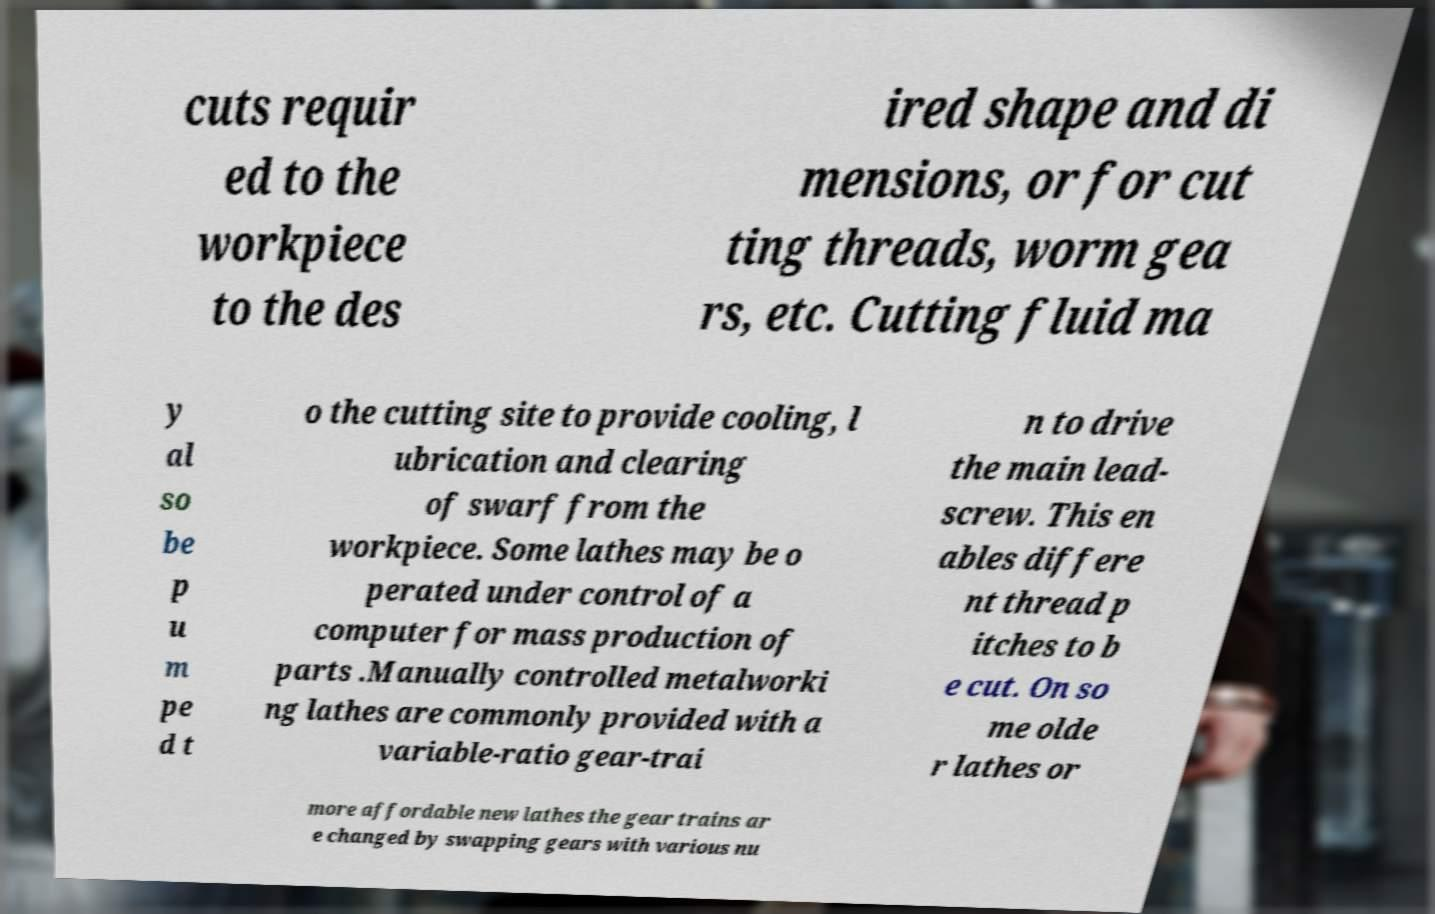Could you assist in decoding the text presented in this image and type it out clearly? cuts requir ed to the workpiece to the des ired shape and di mensions, or for cut ting threads, worm gea rs, etc. Cutting fluid ma y al so be p u m pe d t o the cutting site to provide cooling, l ubrication and clearing of swarf from the workpiece. Some lathes may be o perated under control of a computer for mass production of parts .Manually controlled metalworki ng lathes are commonly provided with a variable-ratio gear-trai n to drive the main lead- screw. This en ables differe nt thread p itches to b e cut. On so me olde r lathes or more affordable new lathes the gear trains ar e changed by swapping gears with various nu 